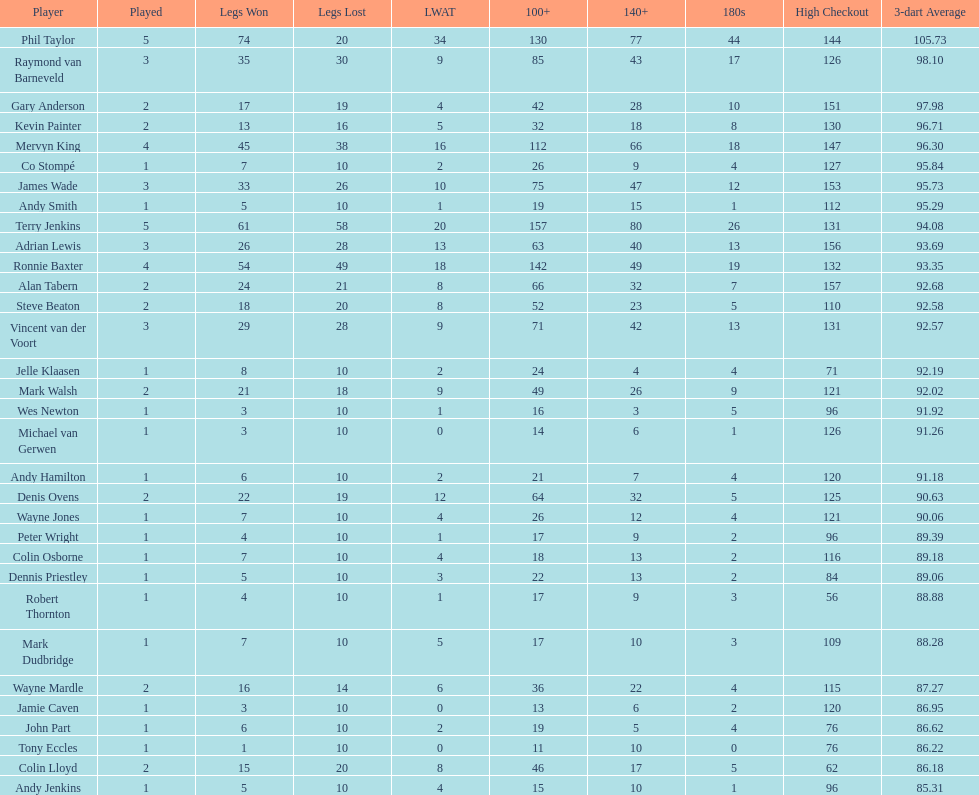Was the 3-dart average for andy smith or kevin painter 9 Kevin Painter. 